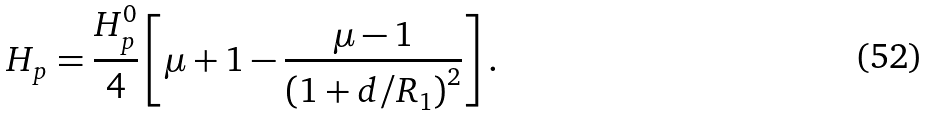Convert formula to latex. <formula><loc_0><loc_0><loc_500><loc_500>H _ { p } = \frac { H _ { p } ^ { 0 } } { 4 } \left [ \mu + 1 - \frac { \mu - 1 } { \left ( 1 + d / R _ { 1 } \right ) ^ { 2 } } \right ] .</formula> 